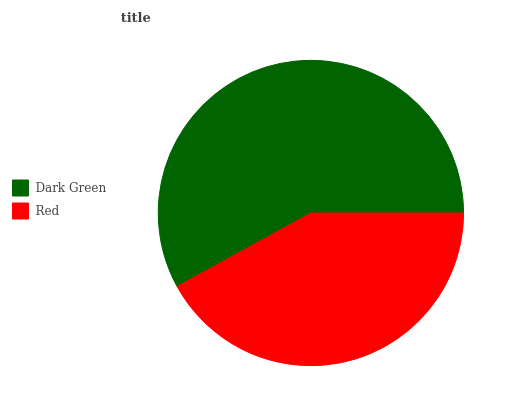Is Red the minimum?
Answer yes or no. Yes. Is Dark Green the maximum?
Answer yes or no. Yes. Is Red the maximum?
Answer yes or no. No. Is Dark Green greater than Red?
Answer yes or no. Yes. Is Red less than Dark Green?
Answer yes or no. Yes. Is Red greater than Dark Green?
Answer yes or no. No. Is Dark Green less than Red?
Answer yes or no. No. Is Dark Green the high median?
Answer yes or no. Yes. Is Red the low median?
Answer yes or no. Yes. Is Red the high median?
Answer yes or no. No. Is Dark Green the low median?
Answer yes or no. No. 